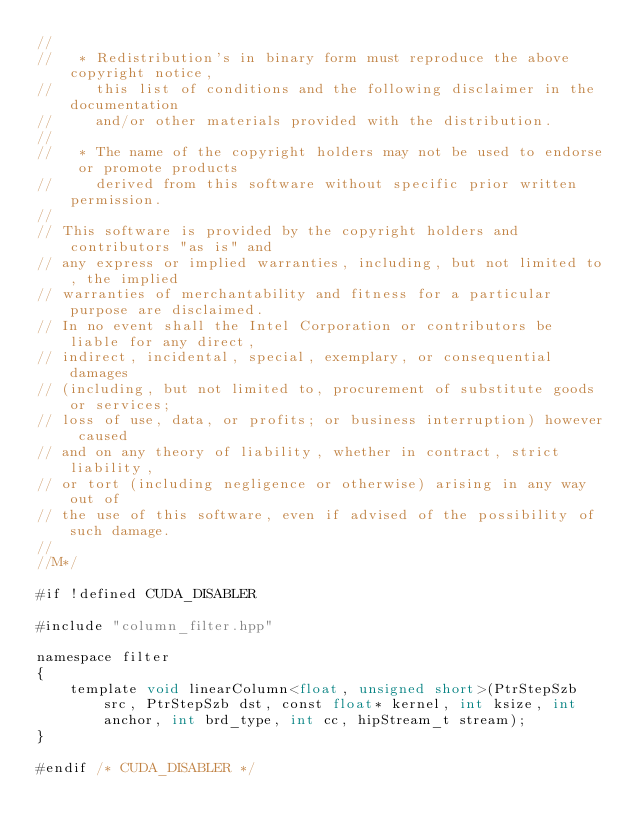Convert code to text. <code><loc_0><loc_0><loc_500><loc_500><_Cuda_>//
//   * Redistribution's in binary form must reproduce the above copyright notice,
//     this list of conditions and the following disclaimer in the documentation
//     and/or other materials provided with the distribution.
//
//   * The name of the copyright holders may not be used to endorse or promote products
//     derived from this software without specific prior written permission.
//
// This software is provided by the copyright holders and contributors "as is" and
// any express or implied warranties, including, but not limited to, the implied
// warranties of merchantability and fitness for a particular purpose are disclaimed.
// In no event shall the Intel Corporation or contributors be liable for any direct,
// indirect, incidental, special, exemplary, or consequential damages
// (including, but not limited to, procurement of substitute goods or services;
// loss of use, data, or profits; or business interruption) however caused
// and on any theory of liability, whether in contract, strict liability,
// or tort (including negligence or otherwise) arising in any way out of
// the use of this software, even if advised of the possibility of such damage.
//
//M*/

#if !defined CUDA_DISABLER

#include "column_filter.hpp"

namespace filter
{
    template void linearColumn<float, unsigned short>(PtrStepSzb src, PtrStepSzb dst, const float* kernel, int ksize, int anchor, int brd_type, int cc, hipStream_t stream);
}

#endif /* CUDA_DISABLER */
</code> 